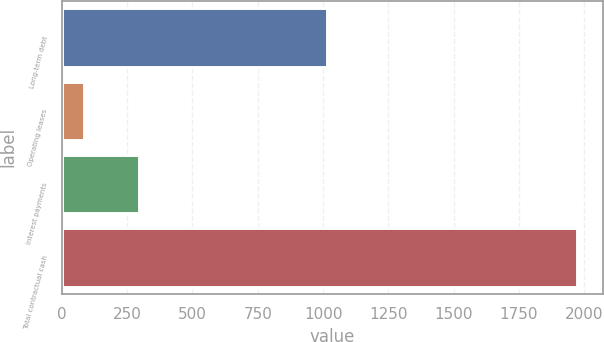<chart> <loc_0><loc_0><loc_500><loc_500><bar_chart><fcel>Long-term debt<fcel>Operating leases<fcel>Interest payments<fcel>Total contractual cash<nl><fcel>1015.8<fcel>86.2<fcel>295.9<fcel>1972.9<nl></chart> 